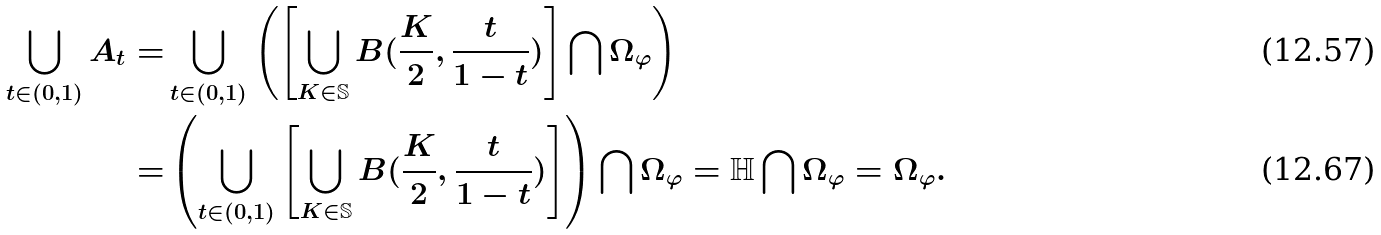<formula> <loc_0><loc_0><loc_500><loc_500>\bigcup _ { t \in ( 0 , 1 ) } A _ { t } = & \bigcup _ { t \in ( 0 , 1 ) } \left ( \left [ \bigcup _ { K \in \mathbb { S } } B ( \frac { K } { 2 } , \frac { t } { 1 - t } ) \right ] \bigcap \Omega _ { \varphi } \right ) \\ = & \left ( \bigcup _ { t \in ( 0 , 1 ) } \left [ \bigcup _ { K \in \mathbb { S } } B ( \frac { K } { 2 } , \frac { t } { 1 - t } ) \right ] \right ) \bigcap \Omega _ { \varphi } = \mathbb { H } \bigcap \Omega _ { \varphi } = \Omega _ { \varphi } .</formula> 